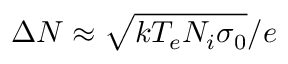<formula> <loc_0><loc_0><loc_500><loc_500>\Delta N \approx \sqrt { k T _ { e } N _ { i } \sigma _ { 0 } } / e</formula> 